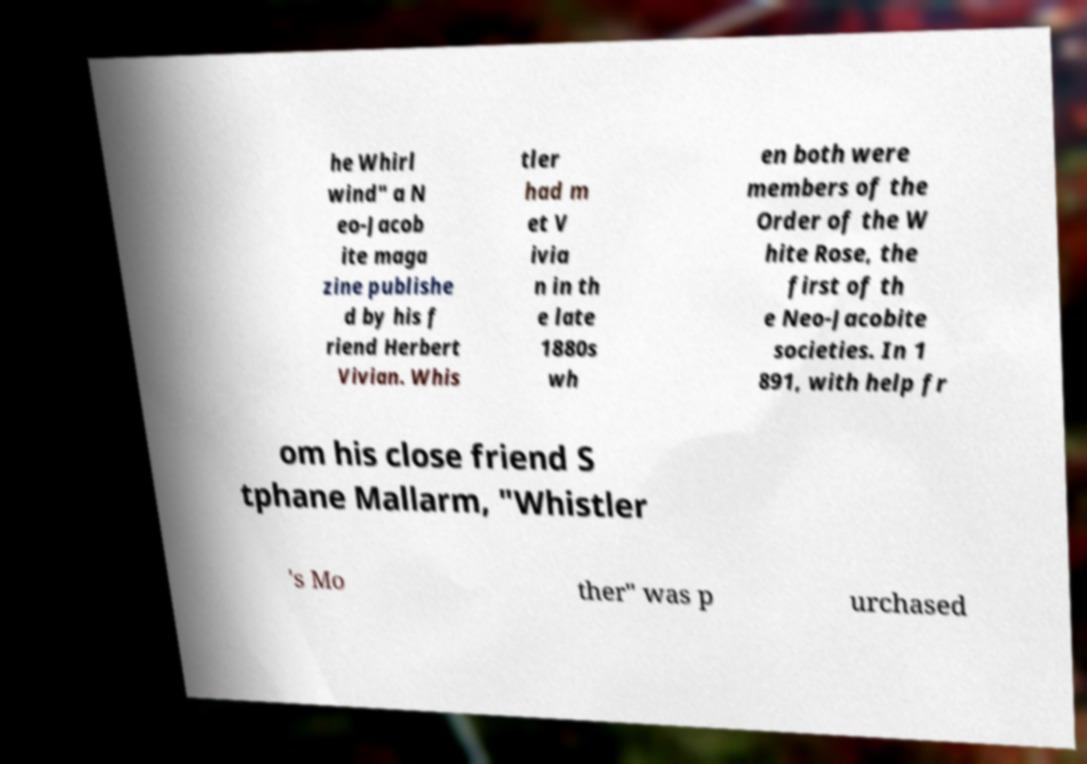Please read and relay the text visible in this image. What does it say? he Whirl wind" a N eo-Jacob ite maga zine publishe d by his f riend Herbert Vivian. Whis tler had m et V ivia n in th e late 1880s wh en both were members of the Order of the W hite Rose, the first of th e Neo-Jacobite societies. In 1 891, with help fr om his close friend S tphane Mallarm, "Whistler 's Mo ther" was p urchased 